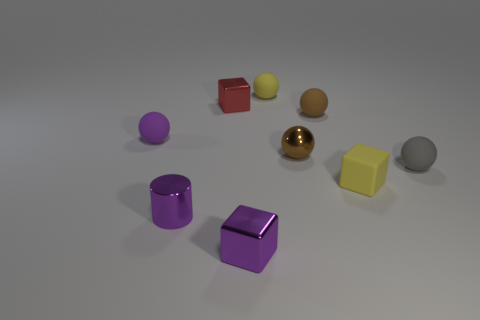What is the material of the red cube that is the same size as the purple cylinder?
Provide a short and direct response. Metal. Are there any cylinders that have the same size as the purple shiny block?
Make the answer very short. Yes. Are there the same number of purple shiny objects behind the gray sphere and purple cylinders that are on the right side of the small rubber cube?
Give a very brief answer. Yes. Are there more tiny spheres than yellow rubber cubes?
Offer a very short reply. Yes. What number of shiny things are small purple cylinders or big objects?
Ensure brevity in your answer.  1. What number of tiny blocks have the same color as the tiny metal cylinder?
Give a very brief answer. 1. There is a ball that is on the left side of the block that is in front of the rubber cube that is in front of the small red shiny thing; what is its material?
Keep it short and to the point. Rubber. What is the color of the rubber thing to the right of the yellow object in front of the small purple matte thing?
Your answer should be very brief. Gray. What number of large things are either brown balls or purple cylinders?
Ensure brevity in your answer.  0. What number of small red blocks have the same material as the tiny cylinder?
Your response must be concise. 1. 